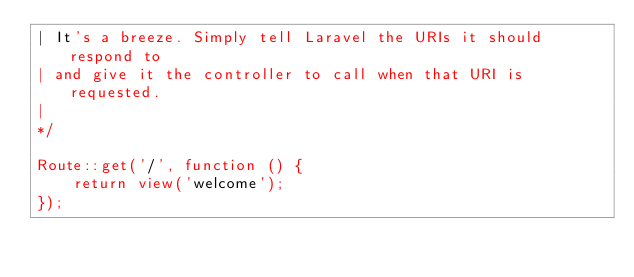Convert code to text. <code><loc_0><loc_0><loc_500><loc_500><_PHP_>| It's a breeze. Simply tell Laravel the URIs it should respond to
| and give it the controller to call when that URI is requested.
|
*/

Route::get('/', function () {
    return view('welcome'); 
});
</code> 